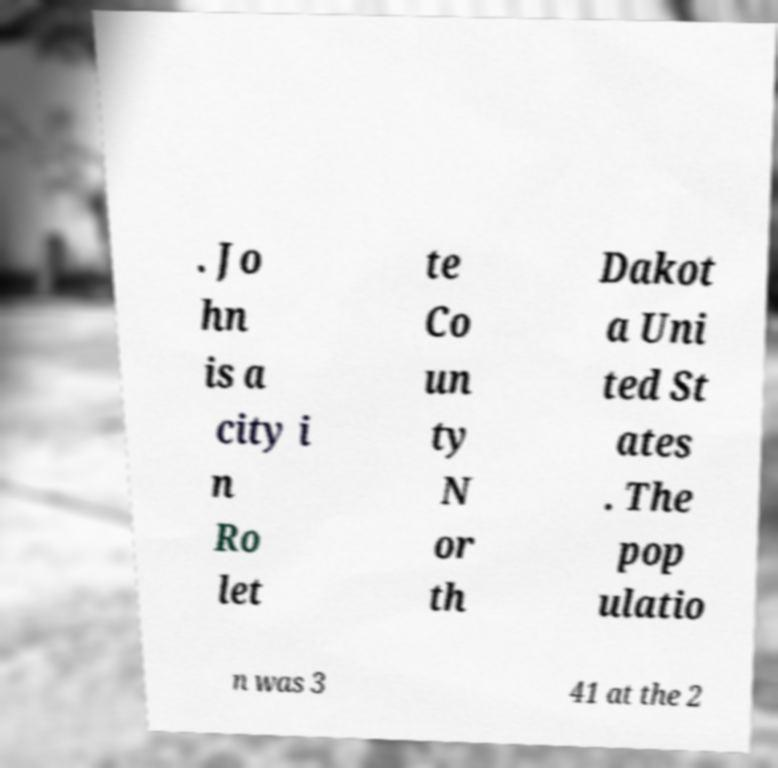There's text embedded in this image that I need extracted. Can you transcribe it verbatim? . Jo hn is a city i n Ro let te Co un ty N or th Dakot a Uni ted St ates . The pop ulatio n was 3 41 at the 2 